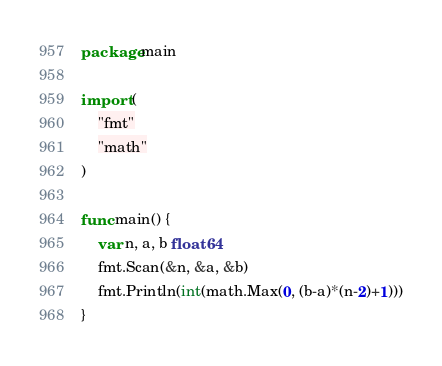<code> <loc_0><loc_0><loc_500><loc_500><_Go_>package main

import (
	"fmt"
	"math"
)

func main() {
	var n, a, b float64
	fmt.Scan(&n, &a, &b)
	fmt.Println(int(math.Max(0, (b-a)*(n-2)+1)))
}
</code> 